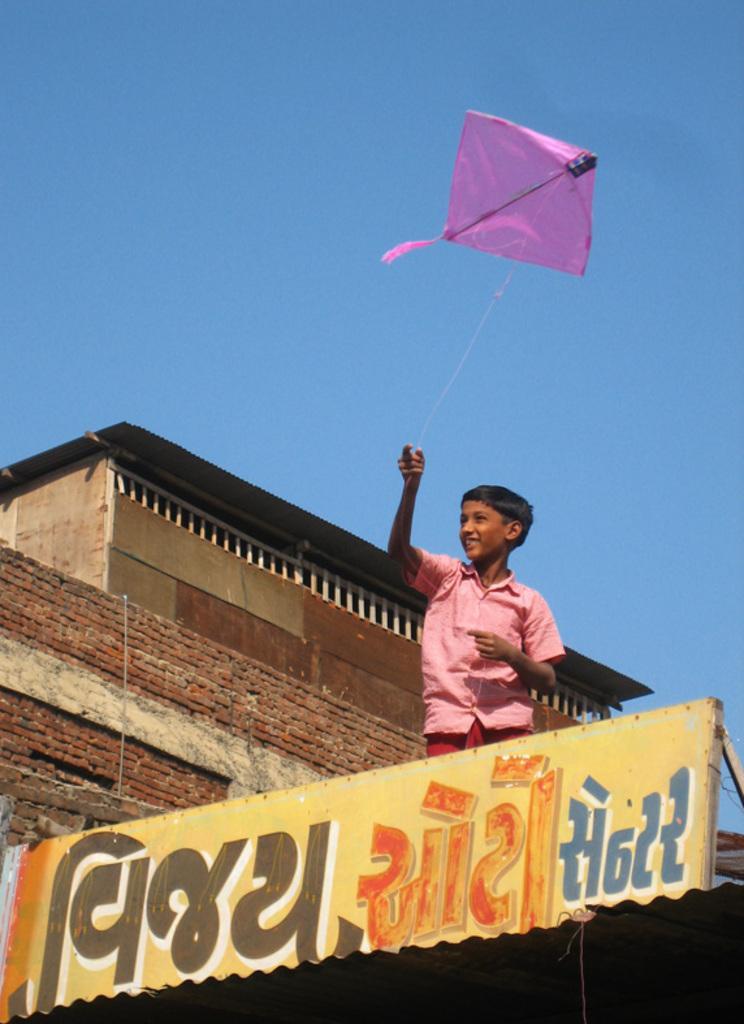How would you summarize this image in a sentence or two? In this image I can see a yellow board in the front and on it I can see something is written. Behind the board I can see a boy is standing and I can see he is wearing a pink colour shirt. I can also see he is holding a thread and on his face I can see smile. In the background I can see a building, the sky and on the top side of the image I can see a pink colour kite in the air. 